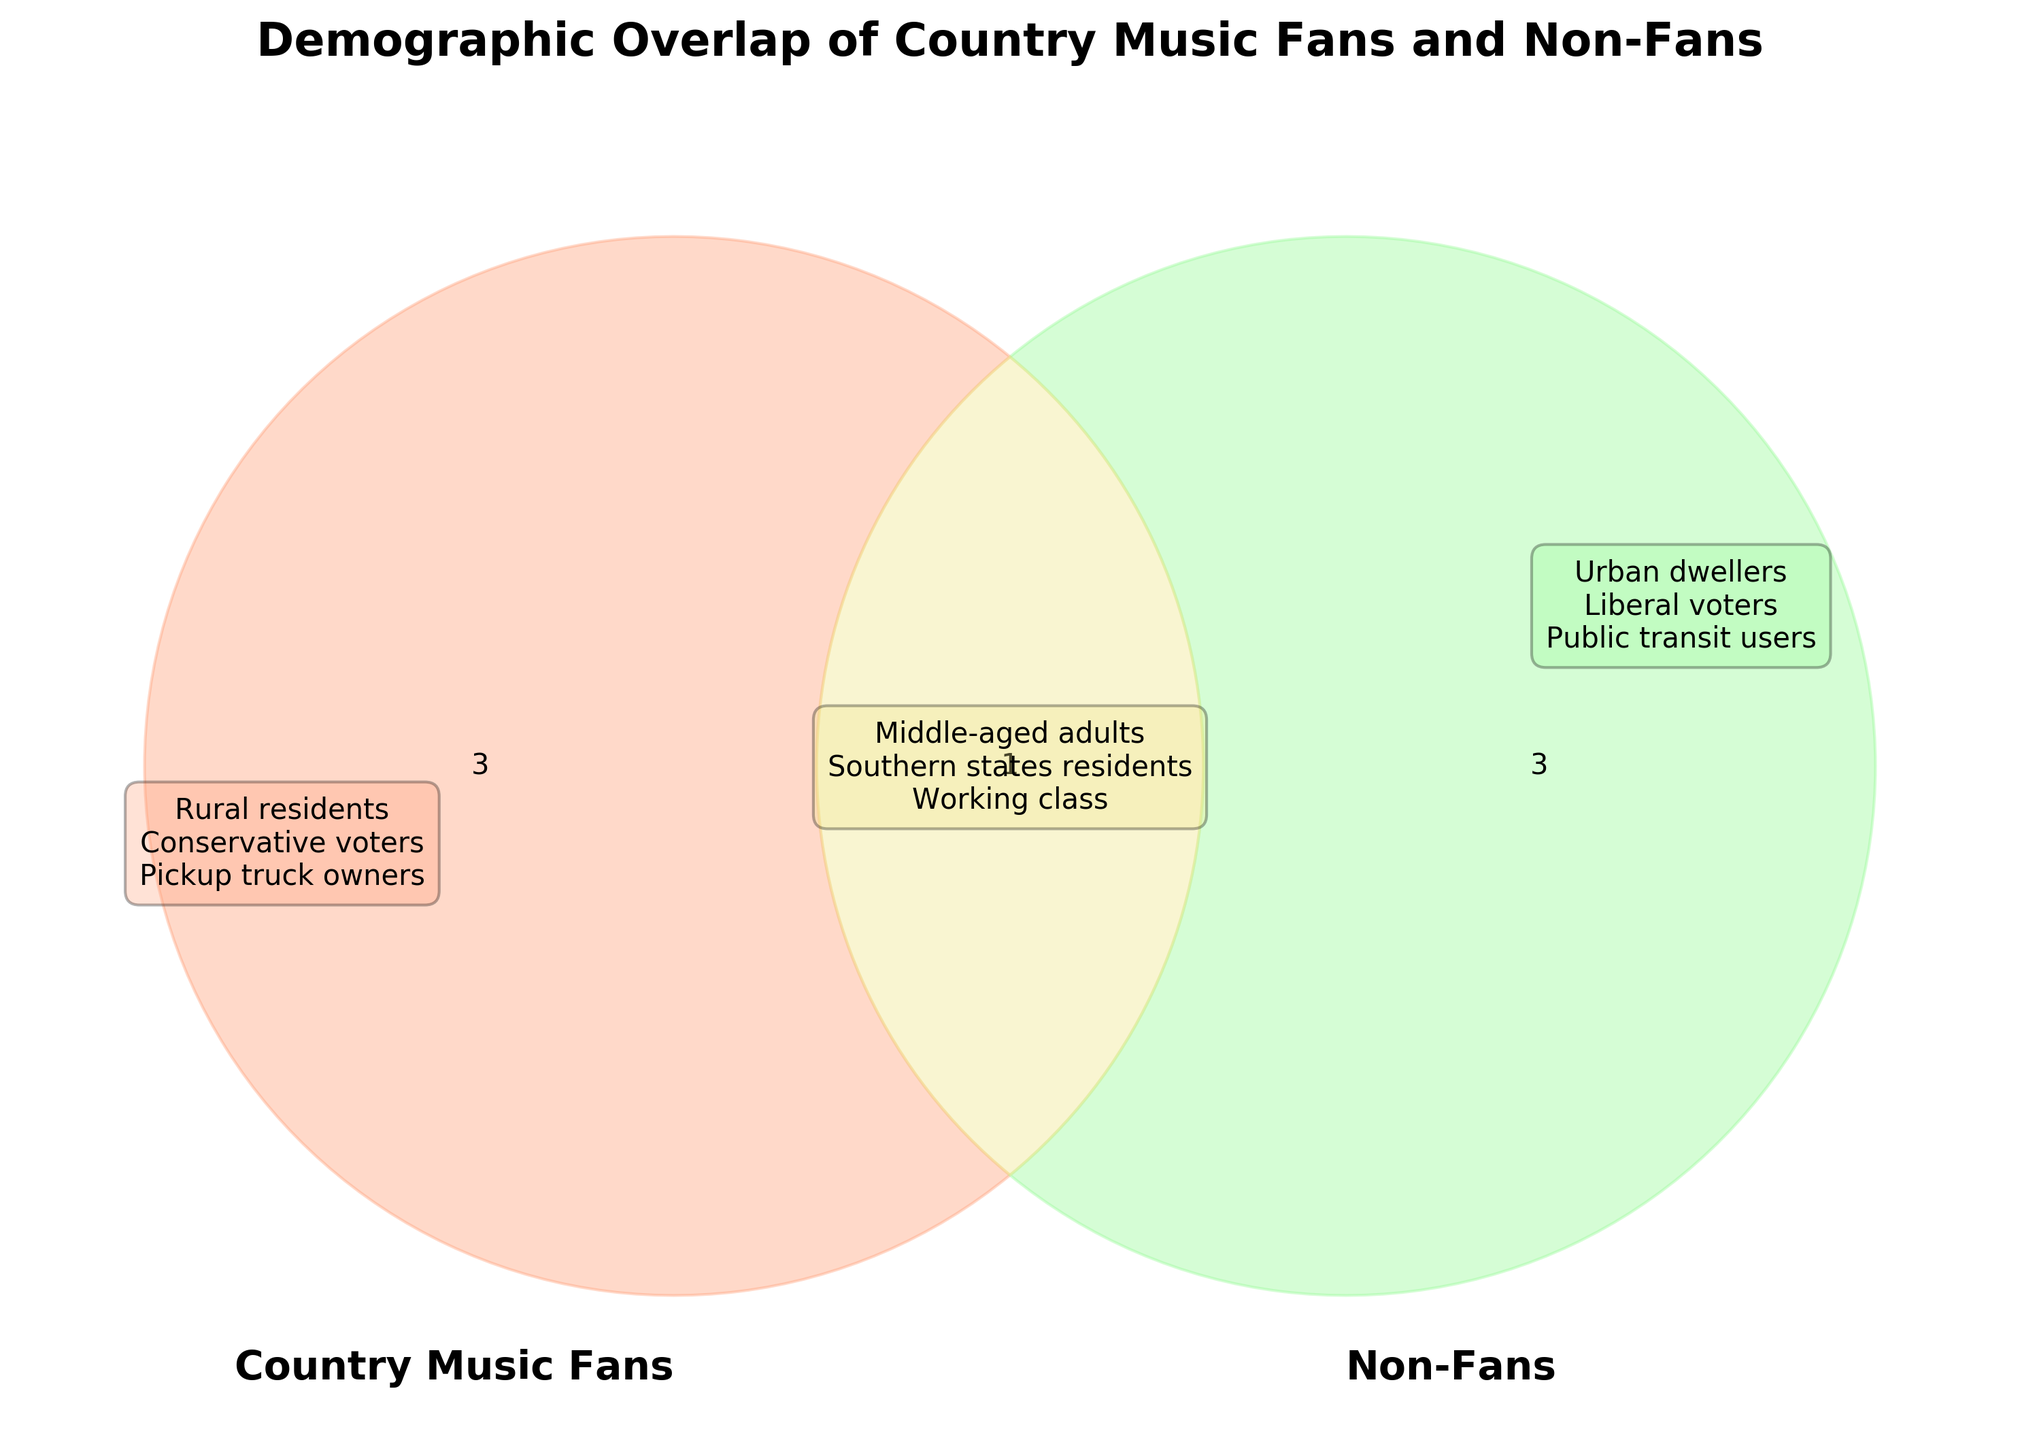What is the title of the Venn Diagram? The title of the Venn Diagram is located at the top of the figure.
Answer: Demographic Overlap of Country Music Fans and Non-Fans Which demographic group is common to both country music fans and non-fans? The overlap section of the Venn Diagram indicates the common demographics.
Answer: Middle-aged adults, Southern states residents, Working class What demographic groups are unique to country music fans? The left circle, representing 'Country Music Fans', lists unique demographics.
Answer: Rural residents, Conservative voters, Pickup truck owners Which color represents the non-fans in the Venn Diagram? The right circle of the Venn Diagram, representing 'Non-Fans', is shaded in a distinct color.
Answer: Green Who are more likely to attend music festivals, country music fans, non-fans, or both? The overlap section of the Venn Diagram indicates shared interests, which includes music festivals.
Answer: Both Which group is represented by the color orange? The left circle's color matches the description provided in the code.
Answer: Country Music Fans Compare the activity of using public transit. Is it associated with country music fans, non-fans, or both? The right circle, representing 'Non-Fans', includes activities such as using public transit.
Answer: Non-Fans Identify a common activity between country music fans and non-fans. The intersection area of the Venn Diagram lists shared activities.
Answer: TV viewers Which demographic is specifically associated with liberal voters? The right circle of the Venn Diagram, representing 'Non-Fans', includes liberal voters.
Answer: Non-Fans 